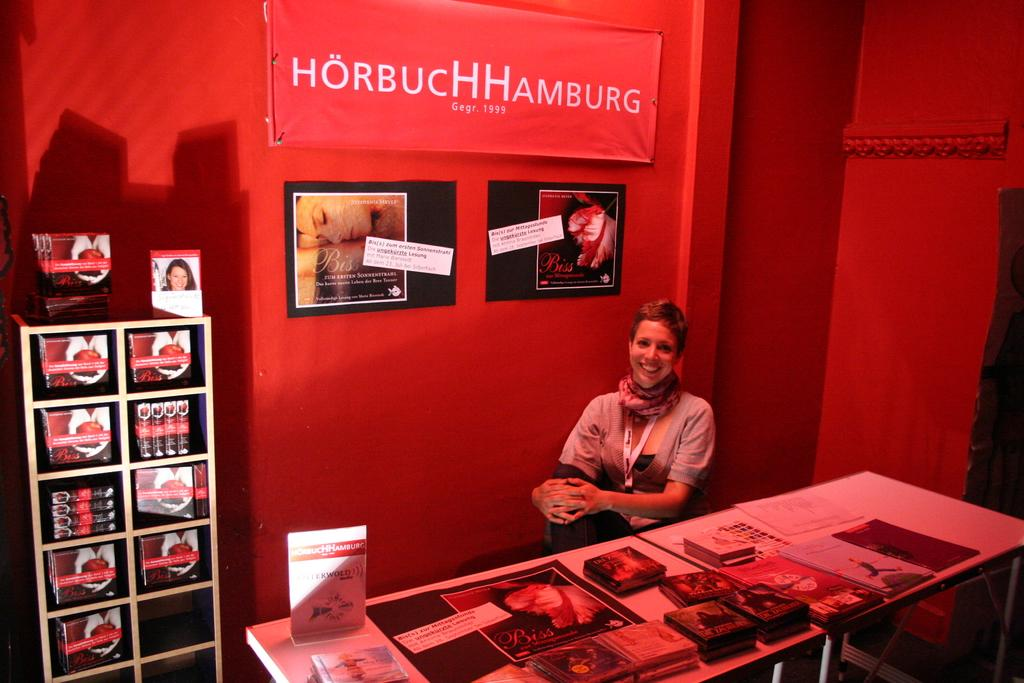<image>
Describe the image concisely. A woman sits in front of a display that reads HorbuchHamburg. 